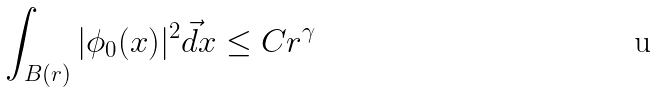<formula> <loc_0><loc_0><loc_500><loc_500>\int _ { B ( r ) } | \phi _ { 0 } ( x ) | ^ { 2 } \vec { d } x \leq C r ^ { \gamma }</formula> 